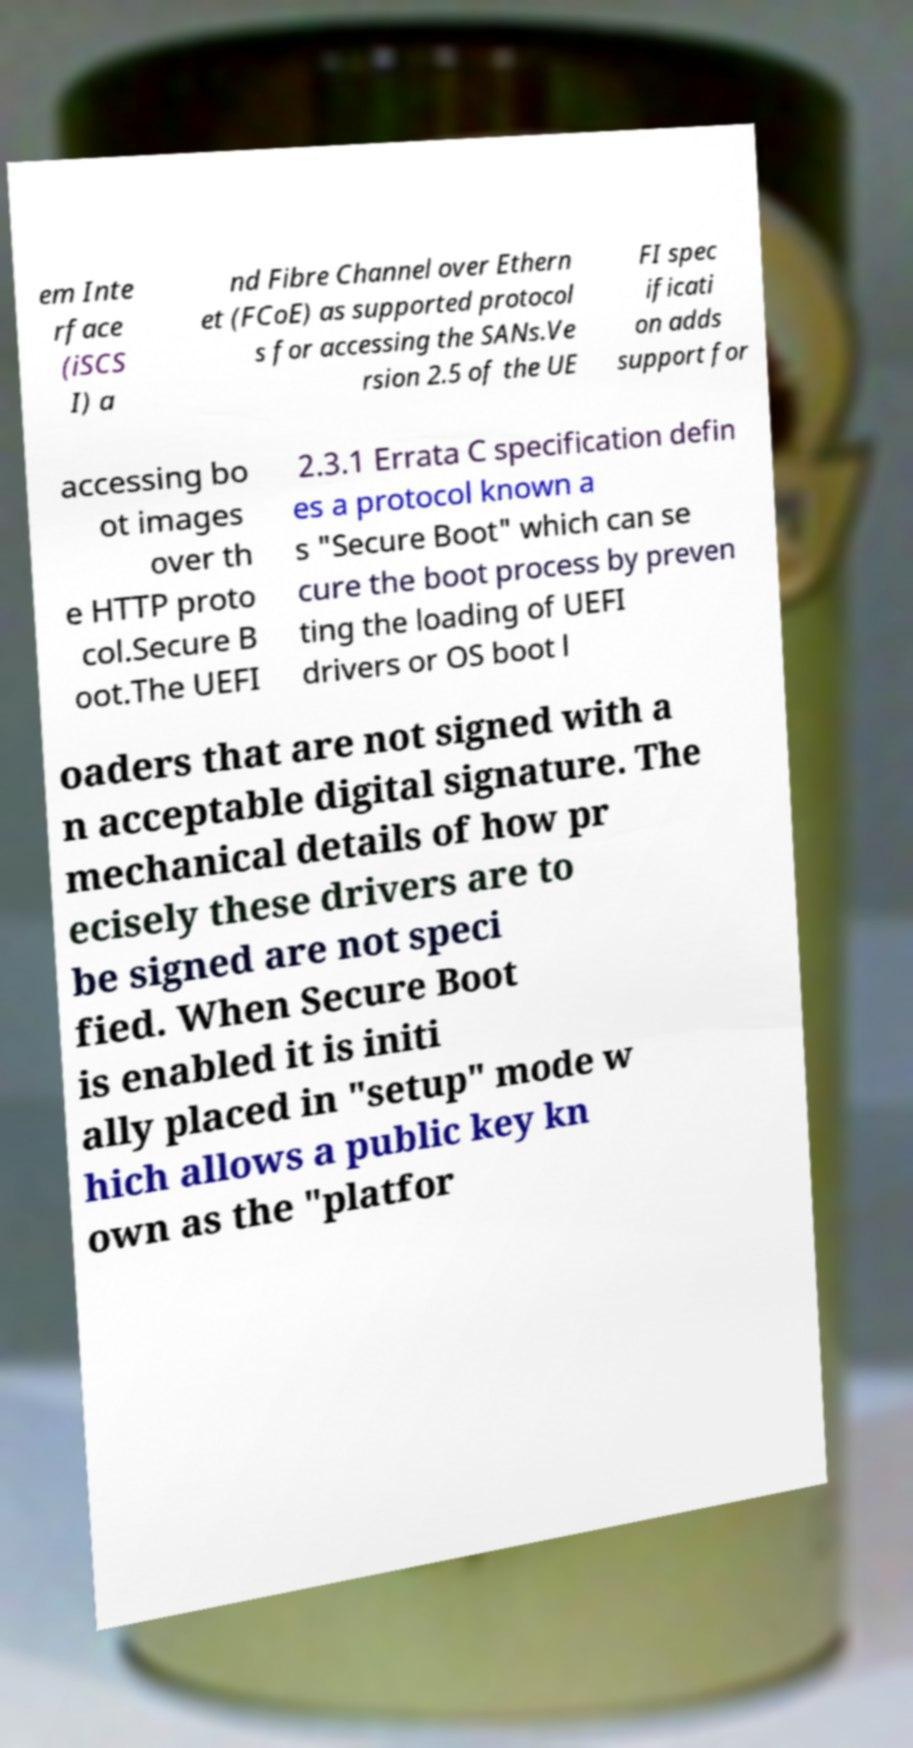There's text embedded in this image that I need extracted. Can you transcribe it verbatim? em Inte rface (iSCS I) a nd Fibre Channel over Ethern et (FCoE) as supported protocol s for accessing the SANs.Ve rsion 2.5 of the UE FI spec ificati on adds support for accessing bo ot images over th e HTTP proto col.Secure B oot.The UEFI 2.3.1 Errata C specification defin es a protocol known a s "Secure Boot" which can se cure the boot process by preven ting the loading of UEFI drivers or OS boot l oaders that are not signed with a n acceptable digital signature. The mechanical details of how pr ecisely these drivers are to be signed are not speci fied. When Secure Boot is enabled it is initi ally placed in "setup" mode w hich allows a public key kn own as the "platfor 